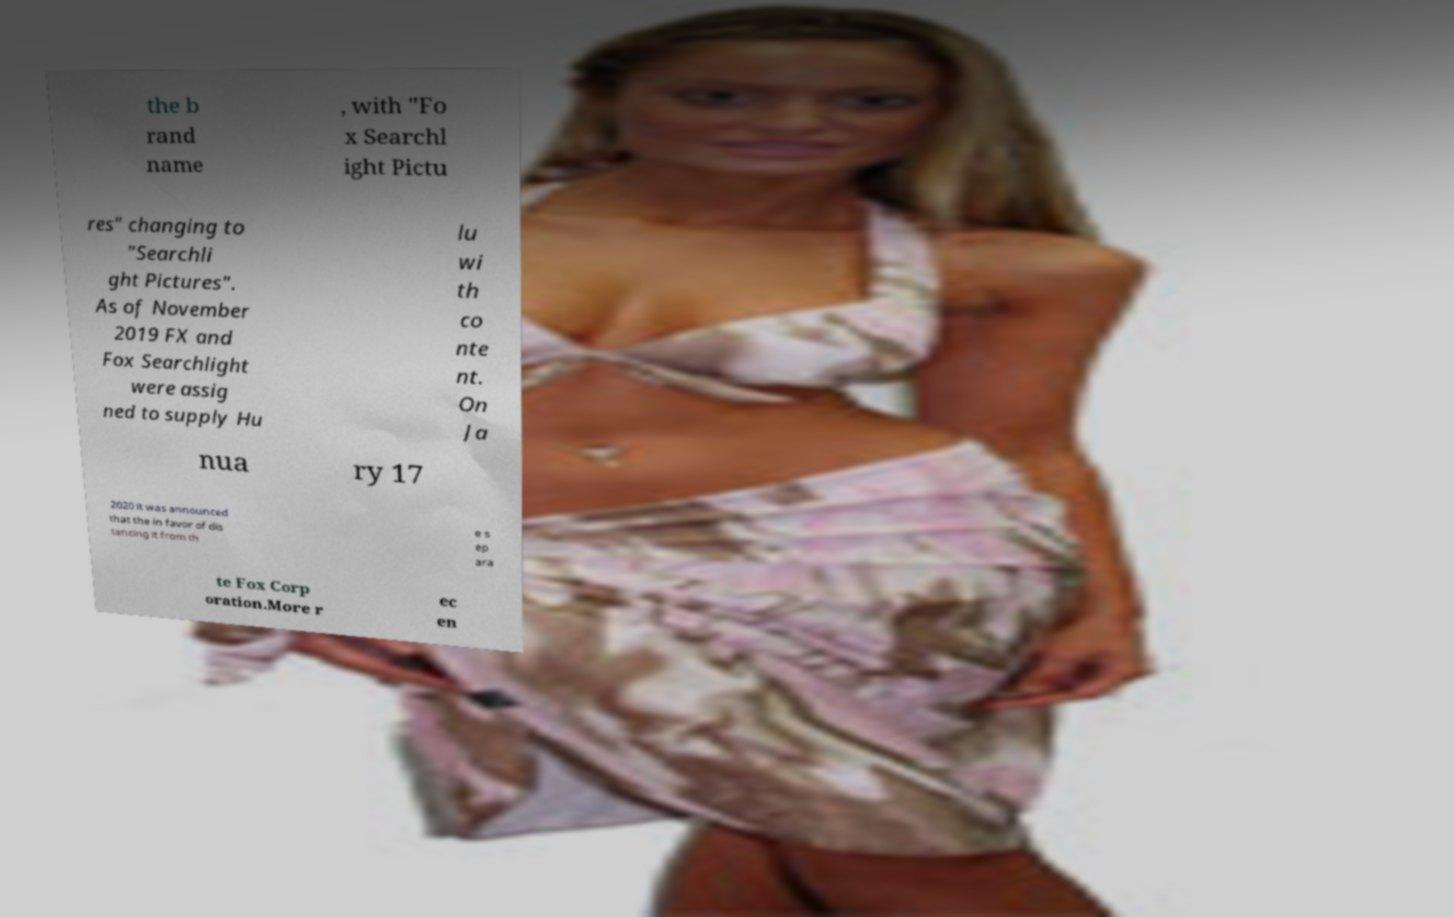For documentation purposes, I need the text within this image transcribed. Could you provide that? the b rand name , with "Fo x Searchl ight Pictu res" changing to "Searchli ght Pictures". As of November 2019 FX and Fox Searchlight were assig ned to supply Hu lu wi th co nte nt. On Ja nua ry 17 2020 it was announced that the in favor of dis tancing it from th e s ep ara te Fox Corp oration.More r ec en 